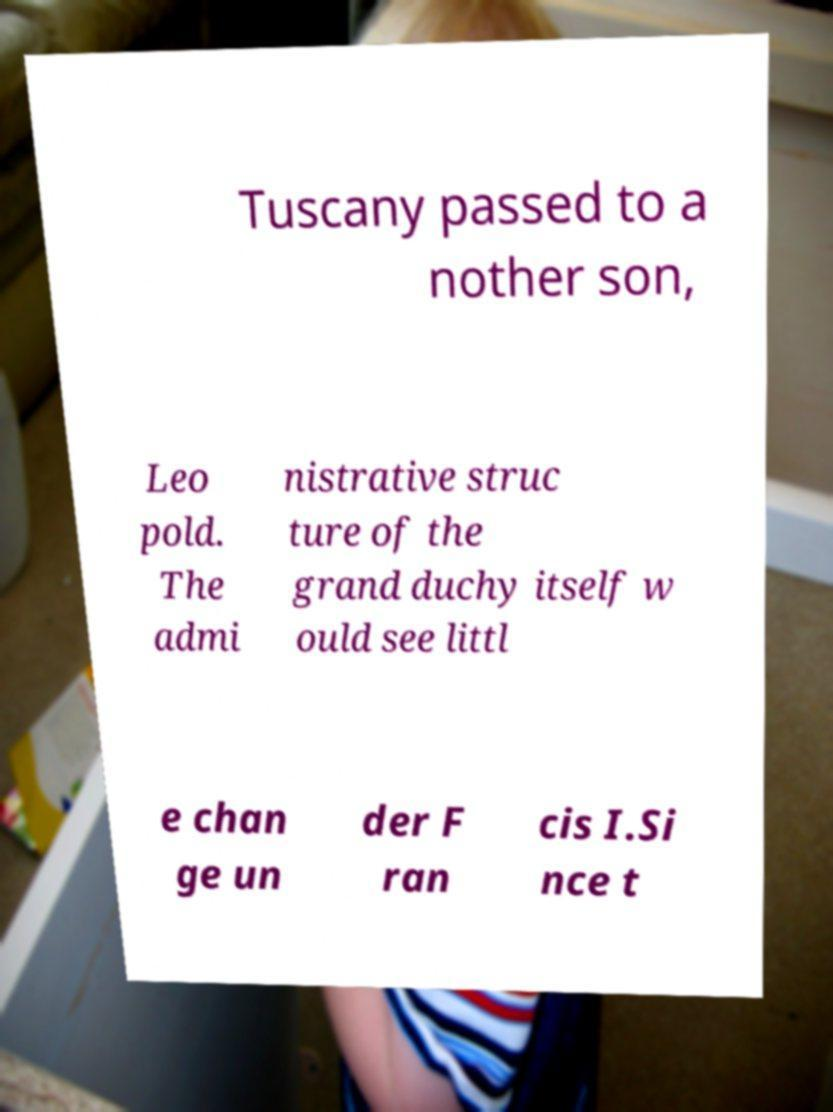There's text embedded in this image that I need extracted. Can you transcribe it verbatim? Tuscany passed to a nother son, Leo pold. The admi nistrative struc ture of the grand duchy itself w ould see littl e chan ge un der F ran cis I.Si nce t 